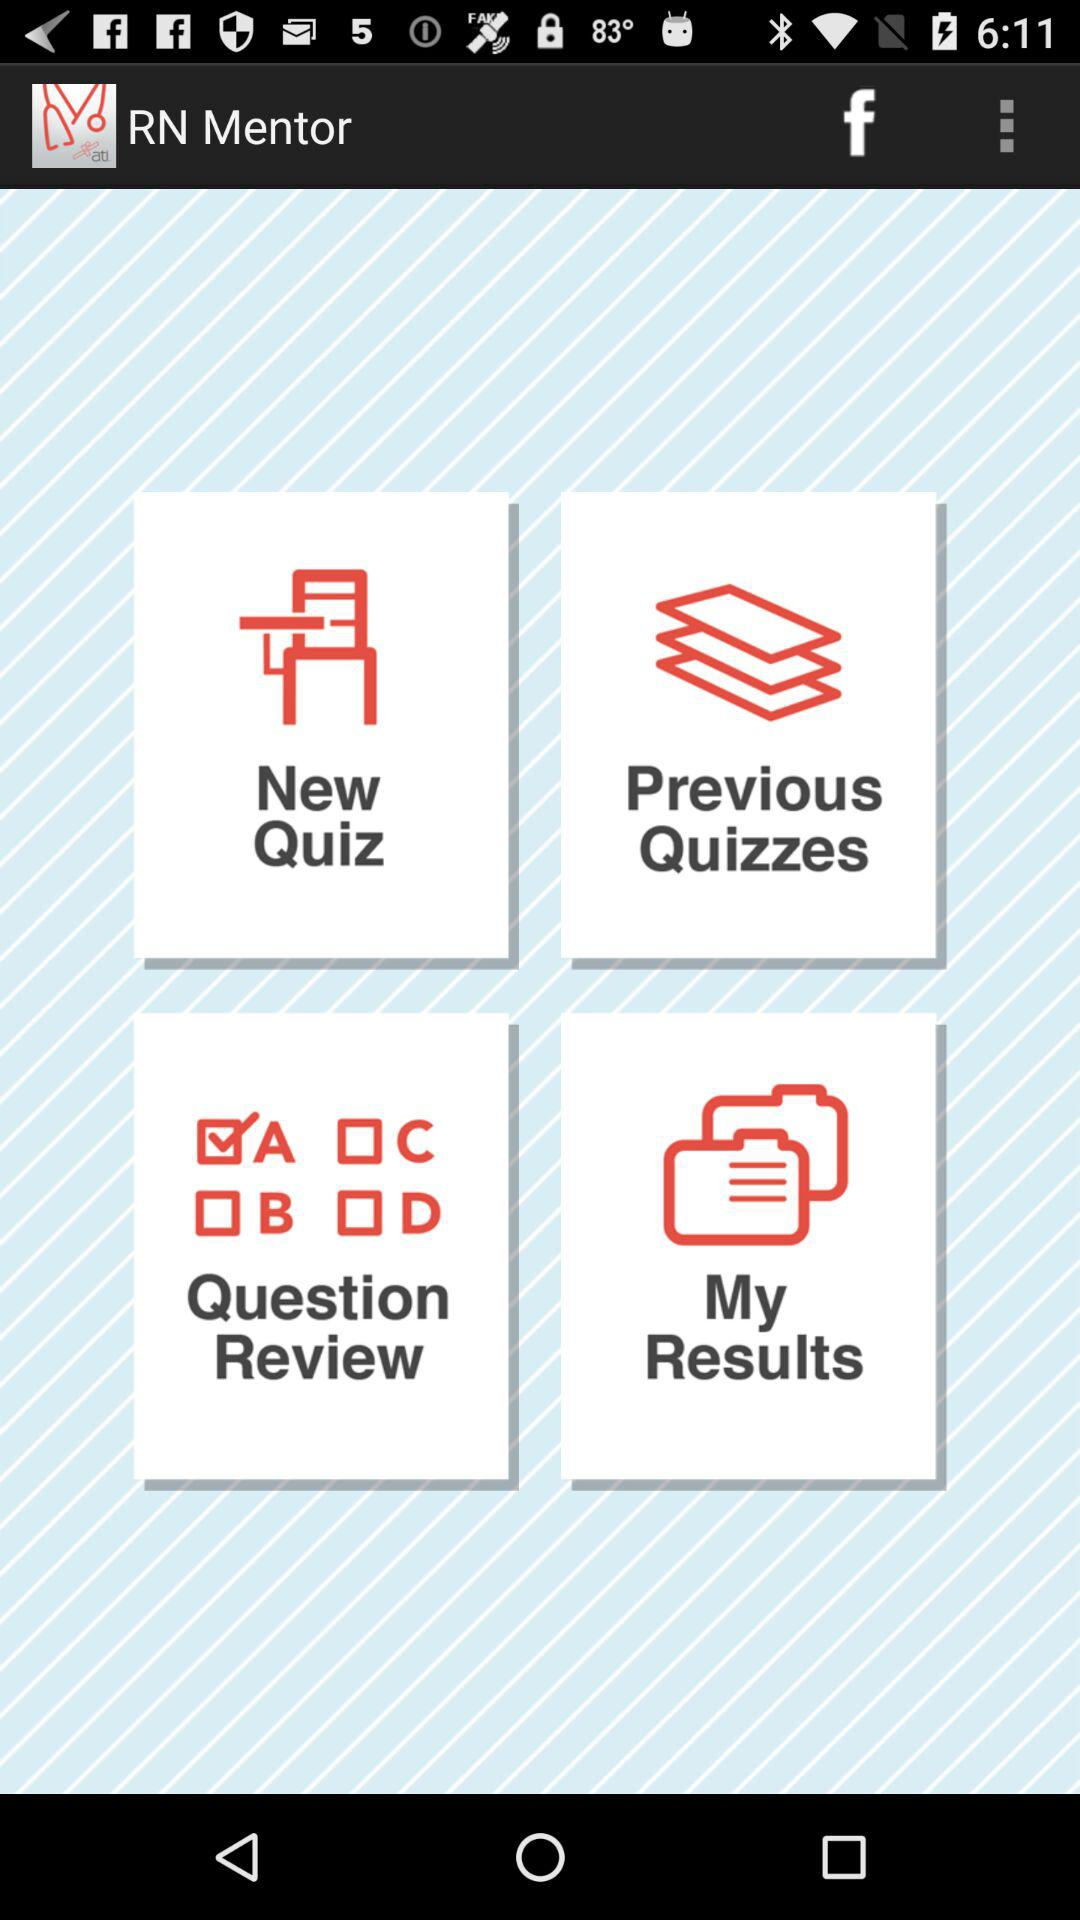What is the application name? The application name is "RN Mentor". 